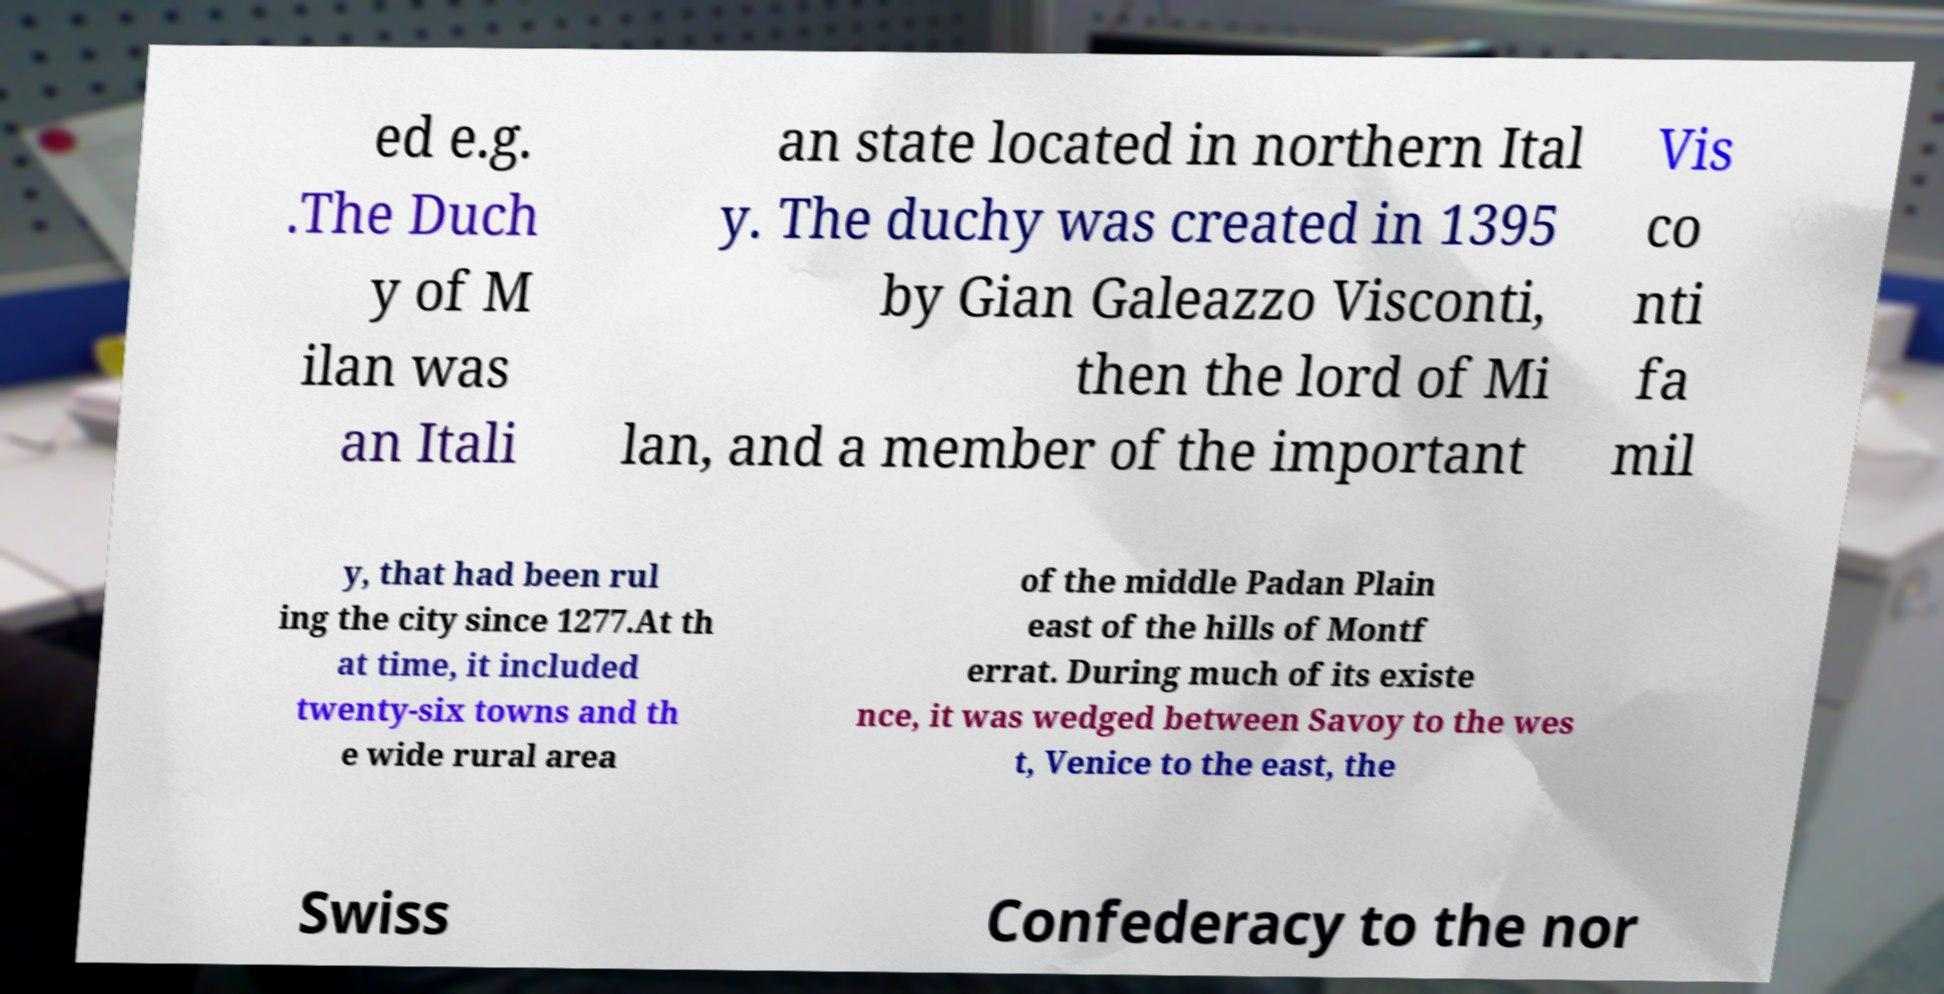What messages or text are displayed in this image? I need them in a readable, typed format. ed e.g. .The Duch y of M ilan was an Itali an state located in northern Ital y. The duchy was created in 1395 by Gian Galeazzo Visconti, then the lord of Mi lan, and a member of the important Vis co nti fa mil y, that had been rul ing the city since 1277.At th at time, it included twenty-six towns and th e wide rural area of the middle Padan Plain east of the hills of Montf errat. During much of its existe nce, it was wedged between Savoy to the wes t, Venice to the east, the Swiss Confederacy to the nor 